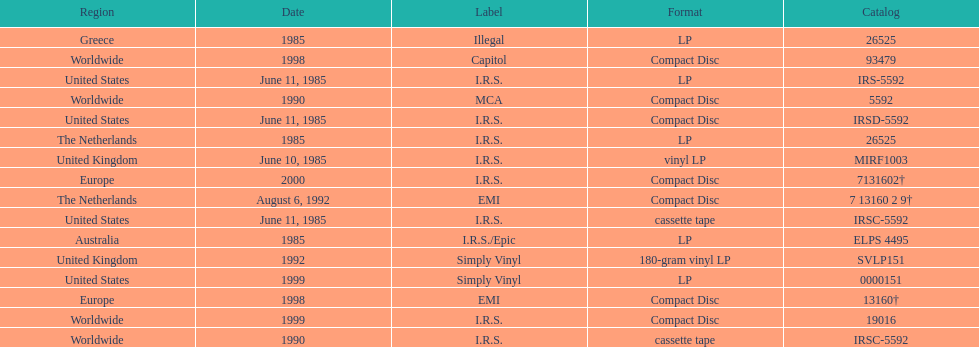Name another region for the 1985 release other than greece. Australia. 